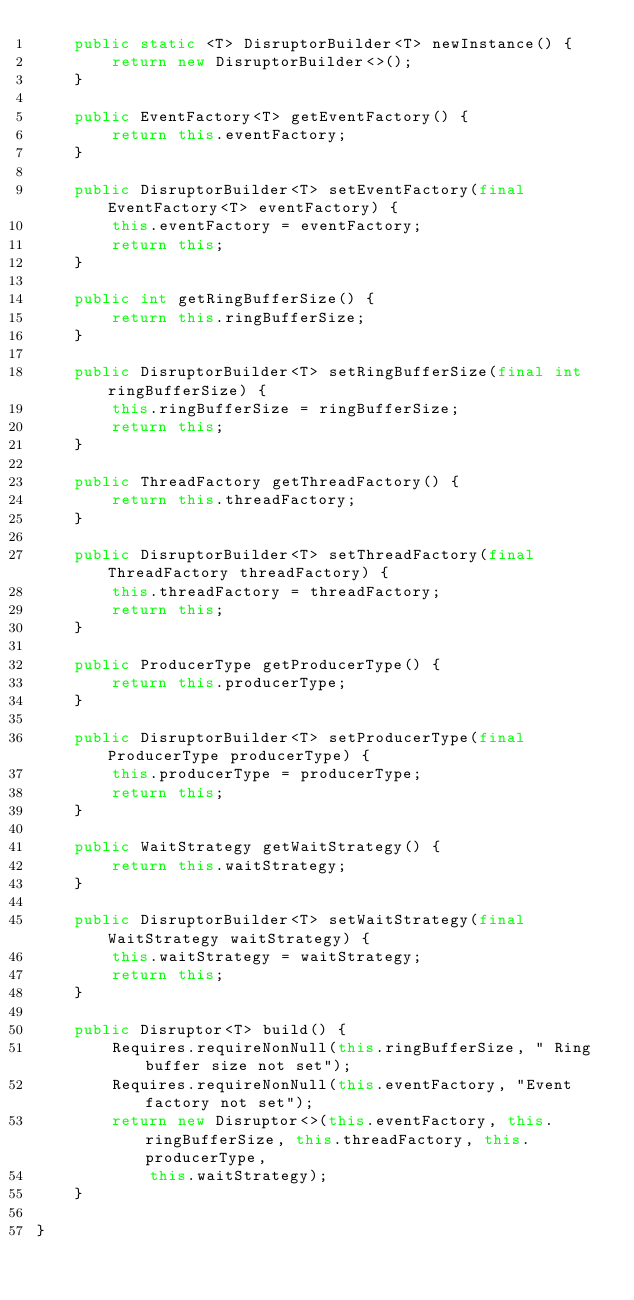<code> <loc_0><loc_0><loc_500><loc_500><_Java_>    public static <T> DisruptorBuilder<T> newInstance() {
        return new DisruptorBuilder<>();
    }

    public EventFactory<T> getEventFactory() {
        return this.eventFactory;
    }

    public DisruptorBuilder<T> setEventFactory(final EventFactory<T> eventFactory) {
        this.eventFactory = eventFactory;
        return this;
    }

    public int getRingBufferSize() {
        return this.ringBufferSize;
    }

    public DisruptorBuilder<T> setRingBufferSize(final int ringBufferSize) {
        this.ringBufferSize = ringBufferSize;
        return this;
    }

    public ThreadFactory getThreadFactory() {
        return this.threadFactory;
    }

    public DisruptorBuilder<T> setThreadFactory(final ThreadFactory threadFactory) {
        this.threadFactory = threadFactory;
        return this;
    }

    public ProducerType getProducerType() {
        return this.producerType;
    }

    public DisruptorBuilder<T> setProducerType(final ProducerType producerType) {
        this.producerType = producerType;
        return this;
    }

    public WaitStrategy getWaitStrategy() {
        return this.waitStrategy;
    }

    public DisruptorBuilder<T> setWaitStrategy(final WaitStrategy waitStrategy) {
        this.waitStrategy = waitStrategy;
        return this;
    }

    public Disruptor<T> build() {
        Requires.requireNonNull(this.ringBufferSize, " Ring buffer size not set");
        Requires.requireNonNull(this.eventFactory, "Event factory not set");
        return new Disruptor<>(this.eventFactory, this.ringBufferSize, this.threadFactory, this.producerType,
            this.waitStrategy);
    }

}
</code> 